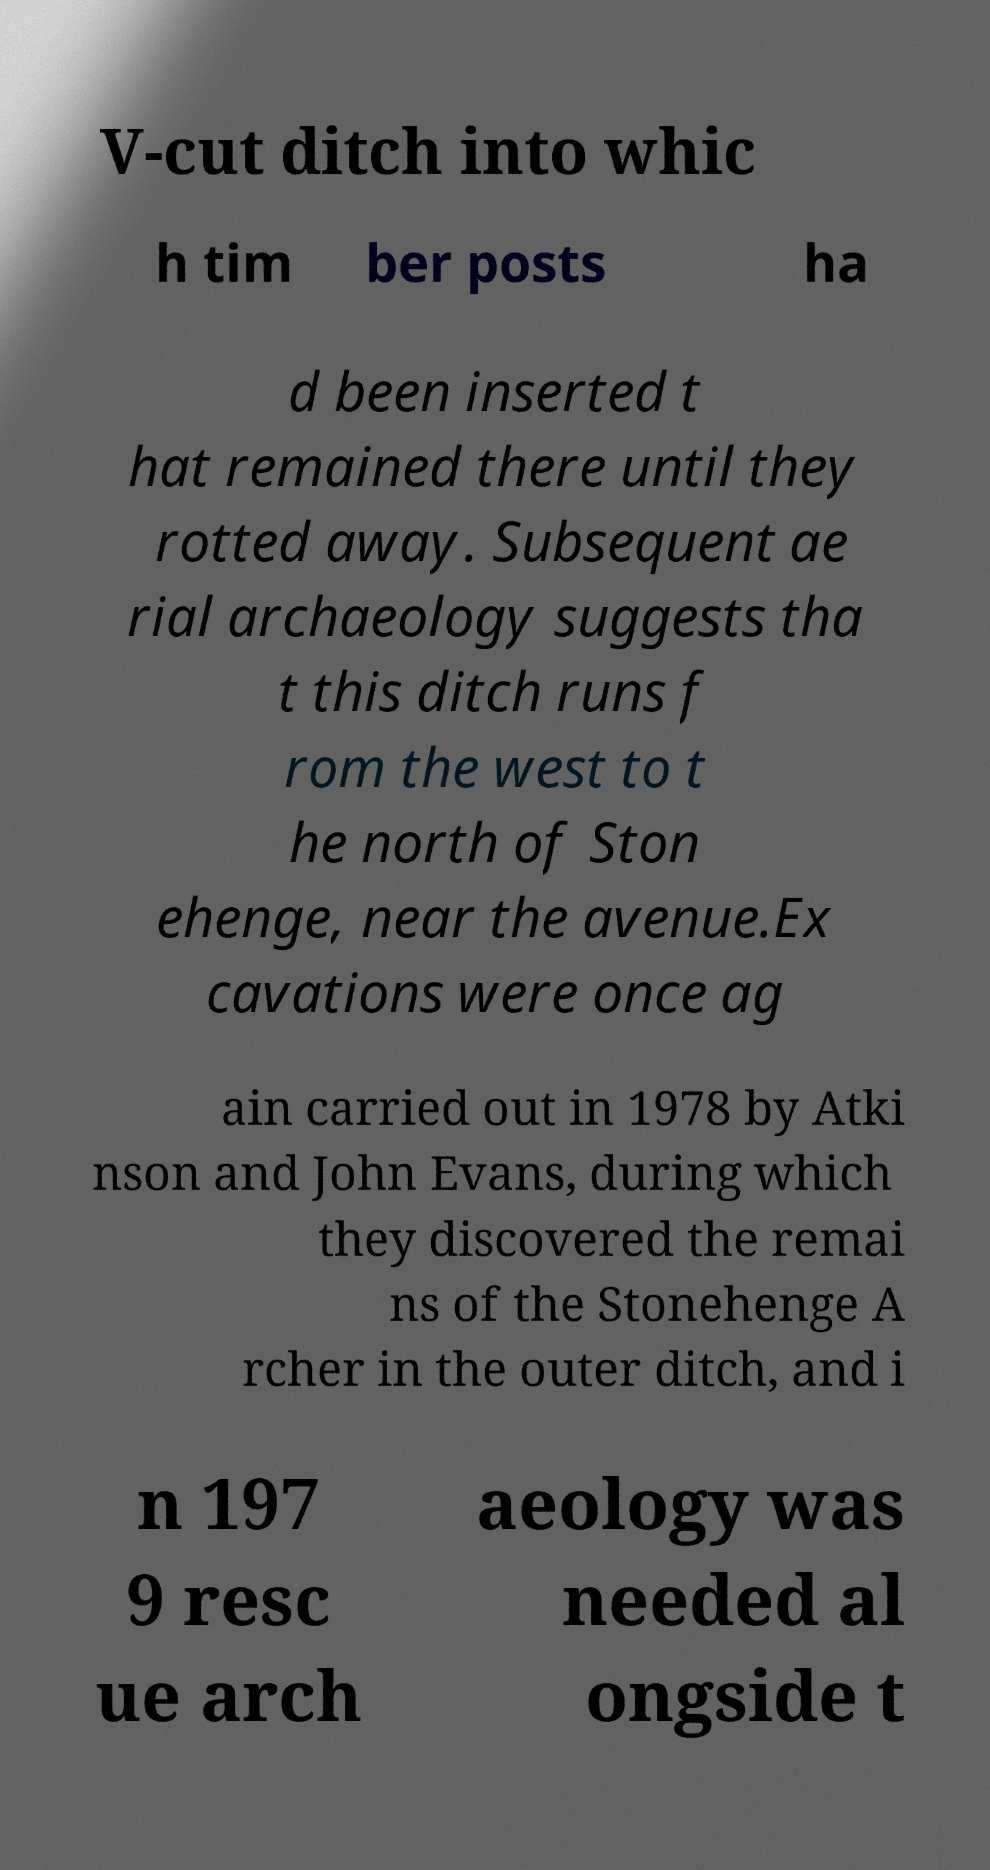Could you assist in decoding the text presented in this image and type it out clearly? V-cut ditch into whic h tim ber posts ha d been inserted t hat remained there until they rotted away. Subsequent ae rial archaeology suggests tha t this ditch runs f rom the west to t he north of Ston ehenge, near the avenue.Ex cavations were once ag ain carried out in 1978 by Atki nson and John Evans, during which they discovered the remai ns of the Stonehenge A rcher in the outer ditch, and i n 197 9 resc ue arch aeology was needed al ongside t 